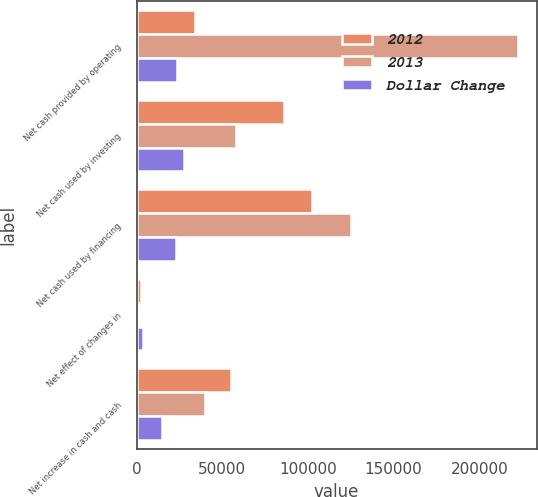Convert chart. <chart><loc_0><loc_0><loc_500><loc_500><stacked_bar_chart><ecel><fcel>Net cash provided by operating<fcel>Net cash used by investing<fcel>Net cash used by financing<fcel>Net effect of changes in<fcel>Net increase in cash and cash<nl><fcel>2012<fcel>34009.5<fcel>86059<fcel>102451<fcel>2414<fcel>55072<nl><fcel>2013<fcel>222408<fcel>58131<fcel>125343<fcel>1157<fcel>40091<nl><fcel>Dollar Change<fcel>23588<fcel>27928<fcel>22892<fcel>3571<fcel>14981<nl></chart> 